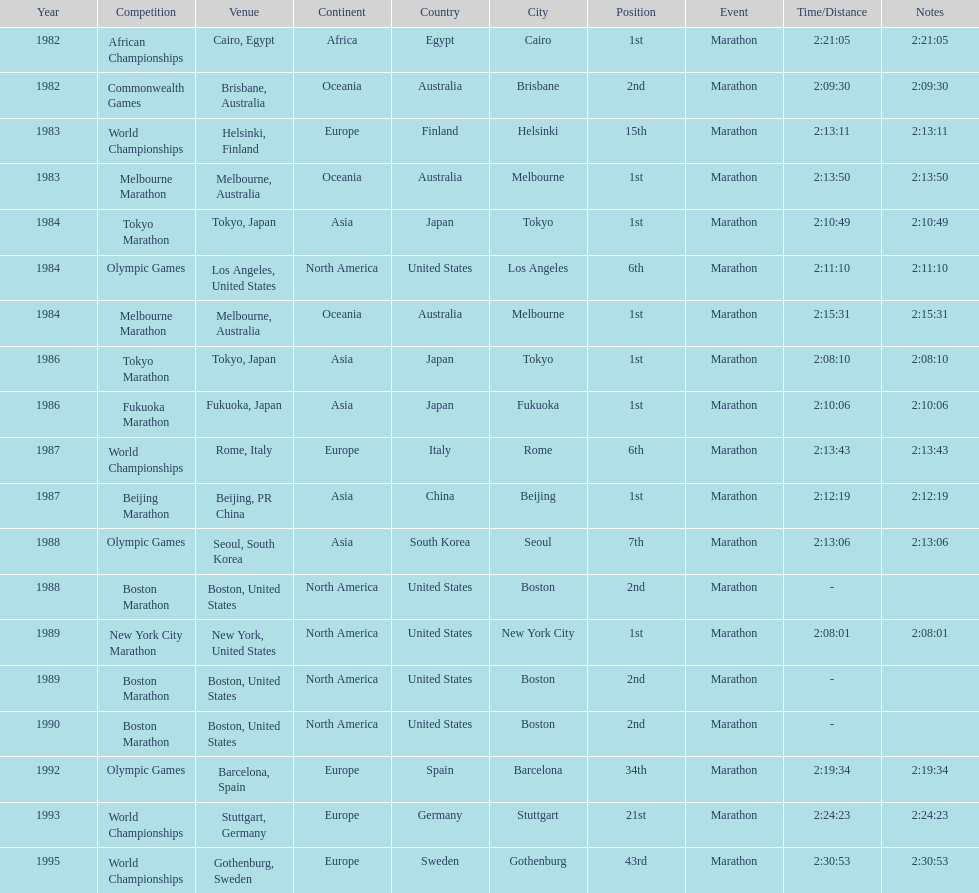In what year did the runner participate in the most marathons? 1984. 